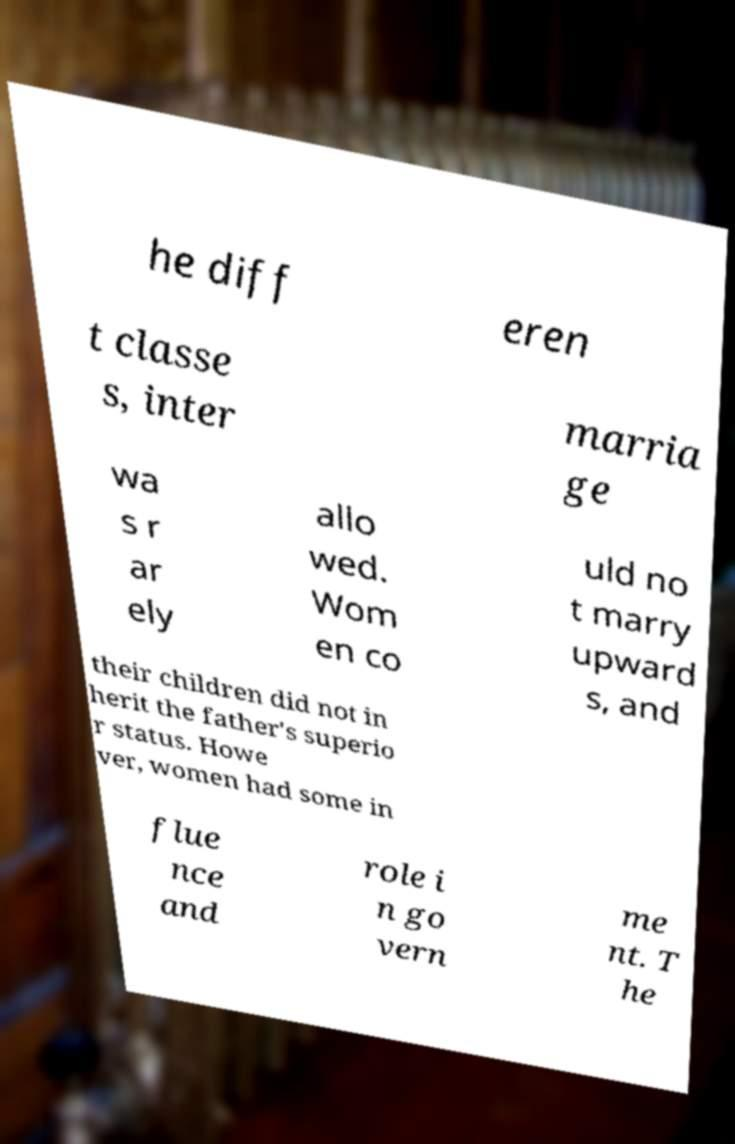Please read and relay the text visible in this image. What does it say? he diff eren t classe s, inter marria ge wa s r ar ely allo wed. Wom en co uld no t marry upward s, and their children did not in herit the father's superio r status. Howe ver, women had some in flue nce and role i n go vern me nt. T he 